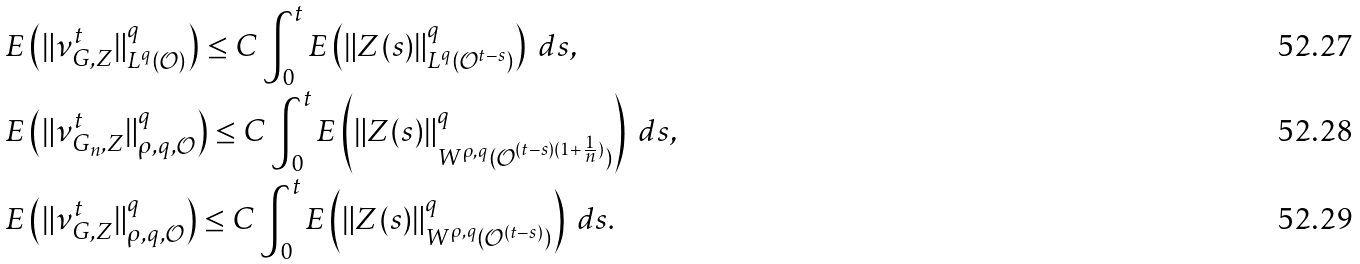Convert formula to latex. <formula><loc_0><loc_0><loc_500><loc_500>& E \left ( \| \nu _ { G , Z } ^ { t } \| ^ { q } _ { L ^ { q } ( \mathcal { O } ) } \right ) \leq C \int _ { 0 } ^ { t } E \left ( \| Z ( s ) \| ^ { q } _ { L ^ { q } ( \mathcal { O } ^ { t - s } ) } \right ) \ d s , \\ & E \left ( \| \nu _ { G _ { n } , Z } ^ { t } \| ^ { q } _ { \rho , q , \mathcal { O } } \right ) \leq C \int _ { 0 } ^ { t } E \left ( \| Z ( s ) \| ^ { q } _ { W ^ { \rho , q } ( \mathcal { O } ^ { ( t - s ) ( 1 + \frac { 1 } { n } ) } ) } \right ) \ d s , \\ & E \left ( \| \nu _ { G , Z } ^ { t } \| ^ { q } _ { \rho , q , \mathcal { O } } \right ) \leq C \int _ { 0 } ^ { t } E \left ( \| Z ( s ) \| ^ { q } _ { W ^ { \rho , q } ( \mathcal { O } ^ { ( t - s ) } ) } \right ) \ d s .</formula> 